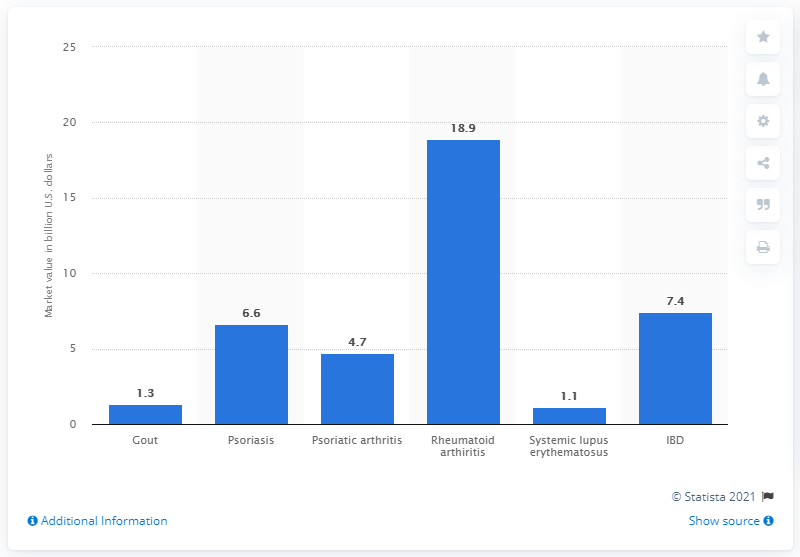List a handful of essential elements in this visual. According to the global gout therapy market in 2015, it was worth 1.3 billion USD. 